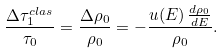Convert formula to latex. <formula><loc_0><loc_0><loc_500><loc_500>\frac { \Delta \tau _ { 1 } ^ { c l a s } } { \tau _ { 0 } } = \frac { \Delta \rho _ { 0 } } { \rho _ { 0 } } = - \frac { u ( E ) \, \frac { d \rho _ { 0 } } { d E } } { \rho _ { 0 } } .</formula> 